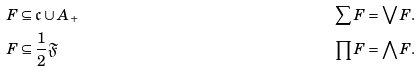<formula> <loc_0><loc_0><loc_500><loc_500>& F \subseteq \mathfrak { c } \cup A _ { + } & \sum F & = \bigvee F . & & \\ & F \subseteq \frac { 1 } { 2 } \mathfrak { F } & \prod F & = \bigwedge F . & &</formula> 